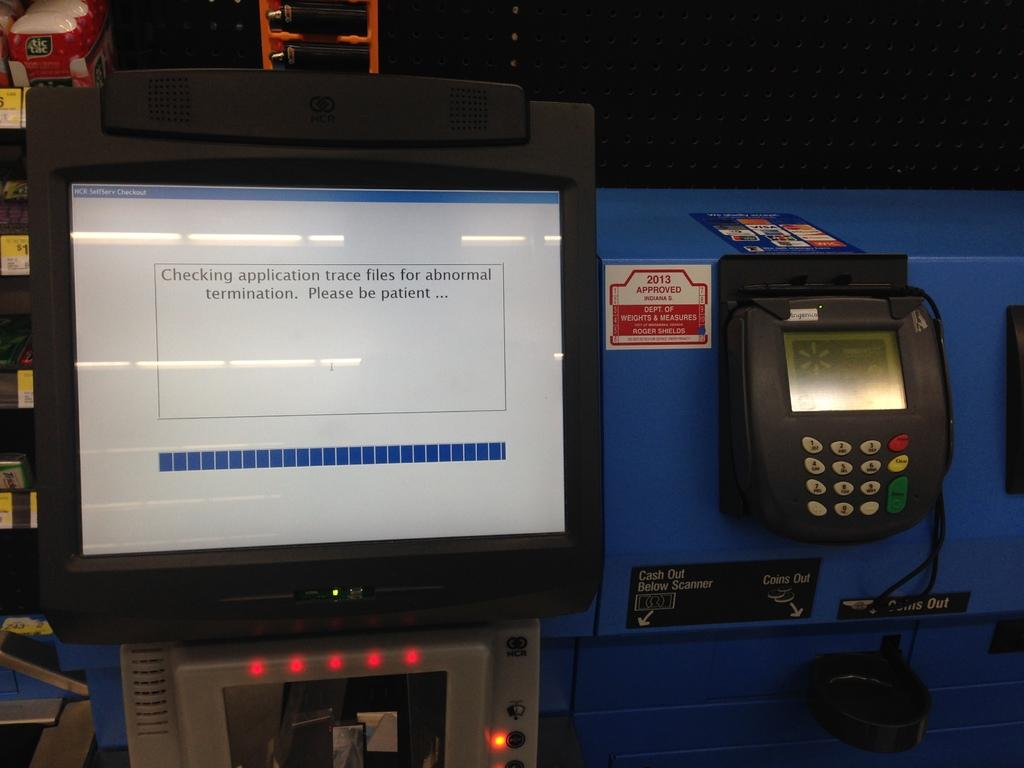What is the main object in the image? There is a machine in the image. What features does the machine have? The machine has buttons and a screen. What type of glass is being exchanged in the image? There is no glass or exchange of any kind present in the image; it only features a machine with buttons and a screen. 